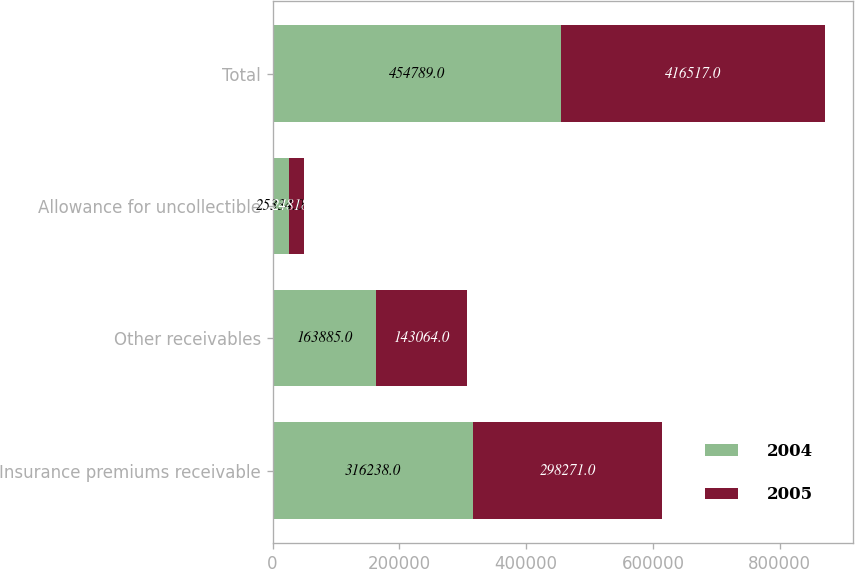<chart> <loc_0><loc_0><loc_500><loc_500><stacked_bar_chart><ecel><fcel>Insurance premiums receivable<fcel>Other receivables<fcel>Allowance for uncollectible<fcel>Total<nl><fcel>2004<fcel>316238<fcel>163885<fcel>25334<fcel>454789<nl><fcel>2005<fcel>298271<fcel>143064<fcel>24818<fcel>416517<nl></chart> 